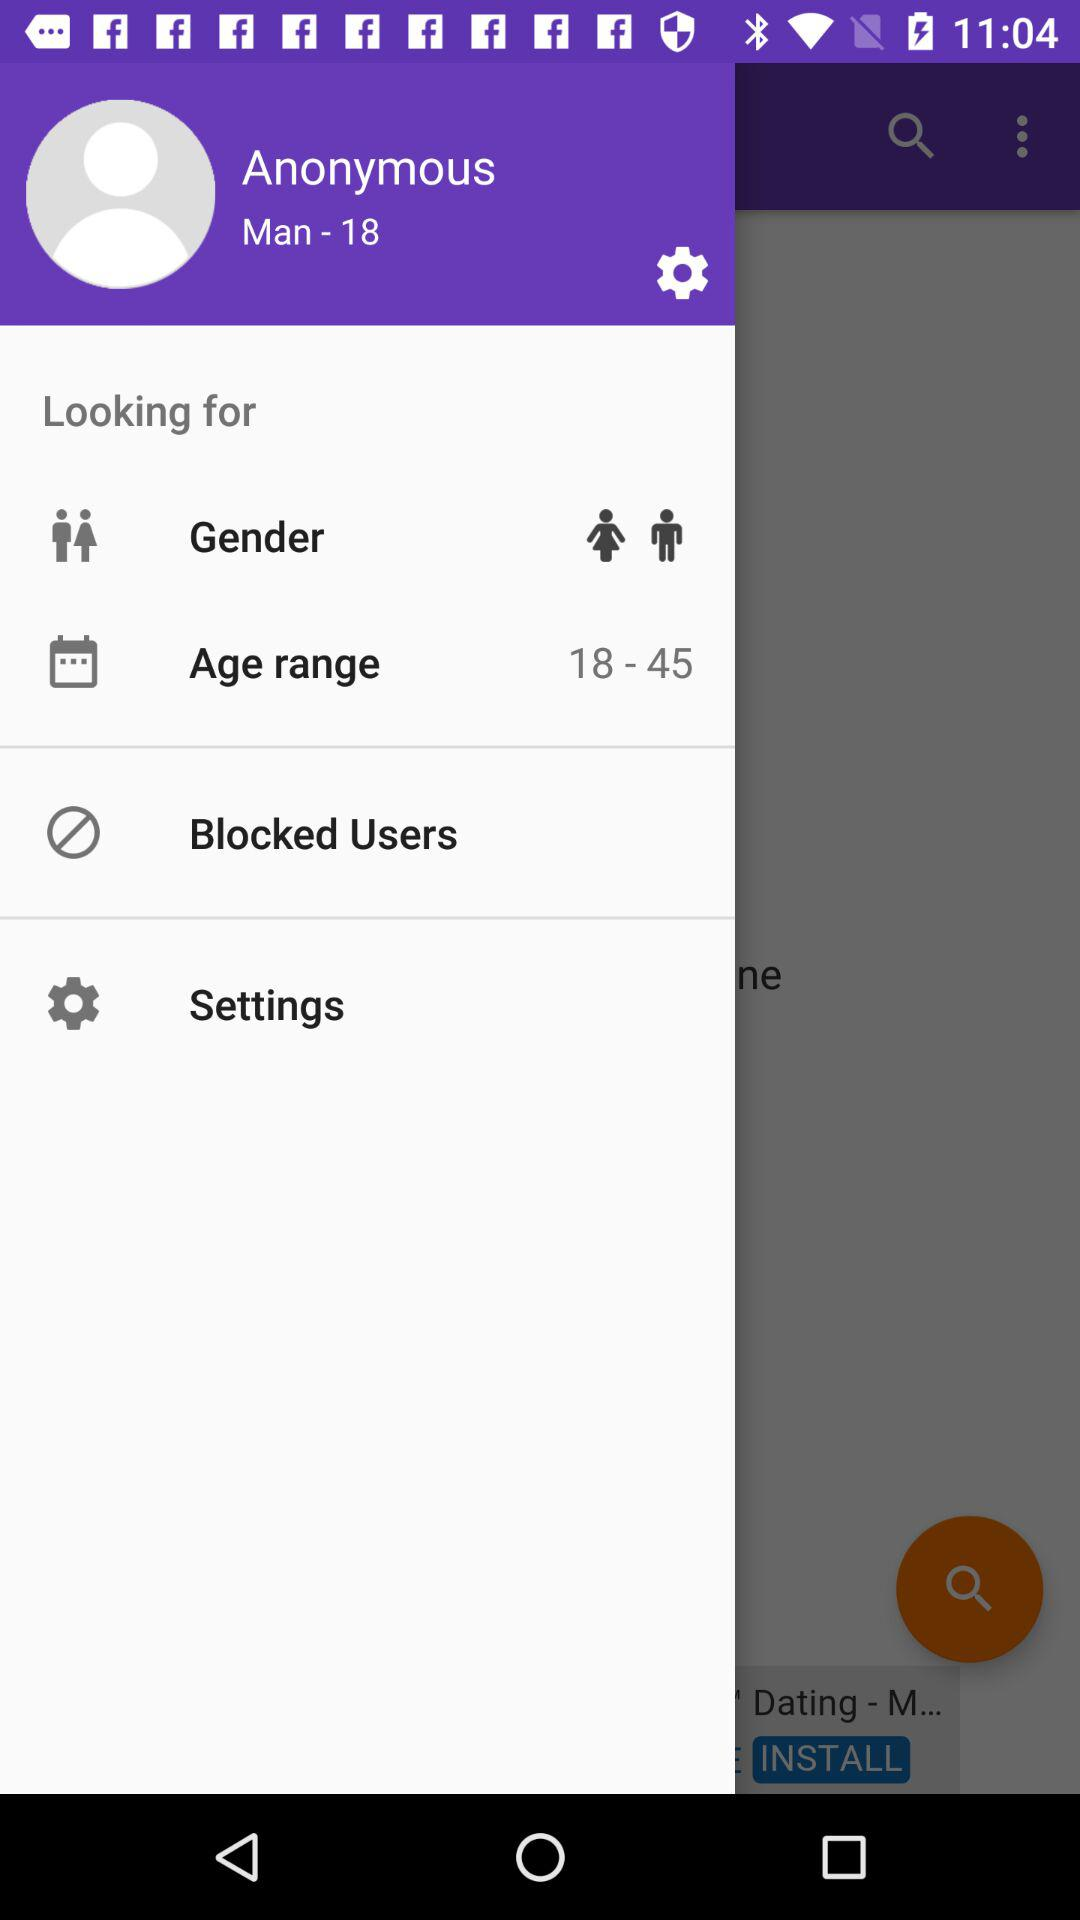What is the username? The username is "Anonymous". 